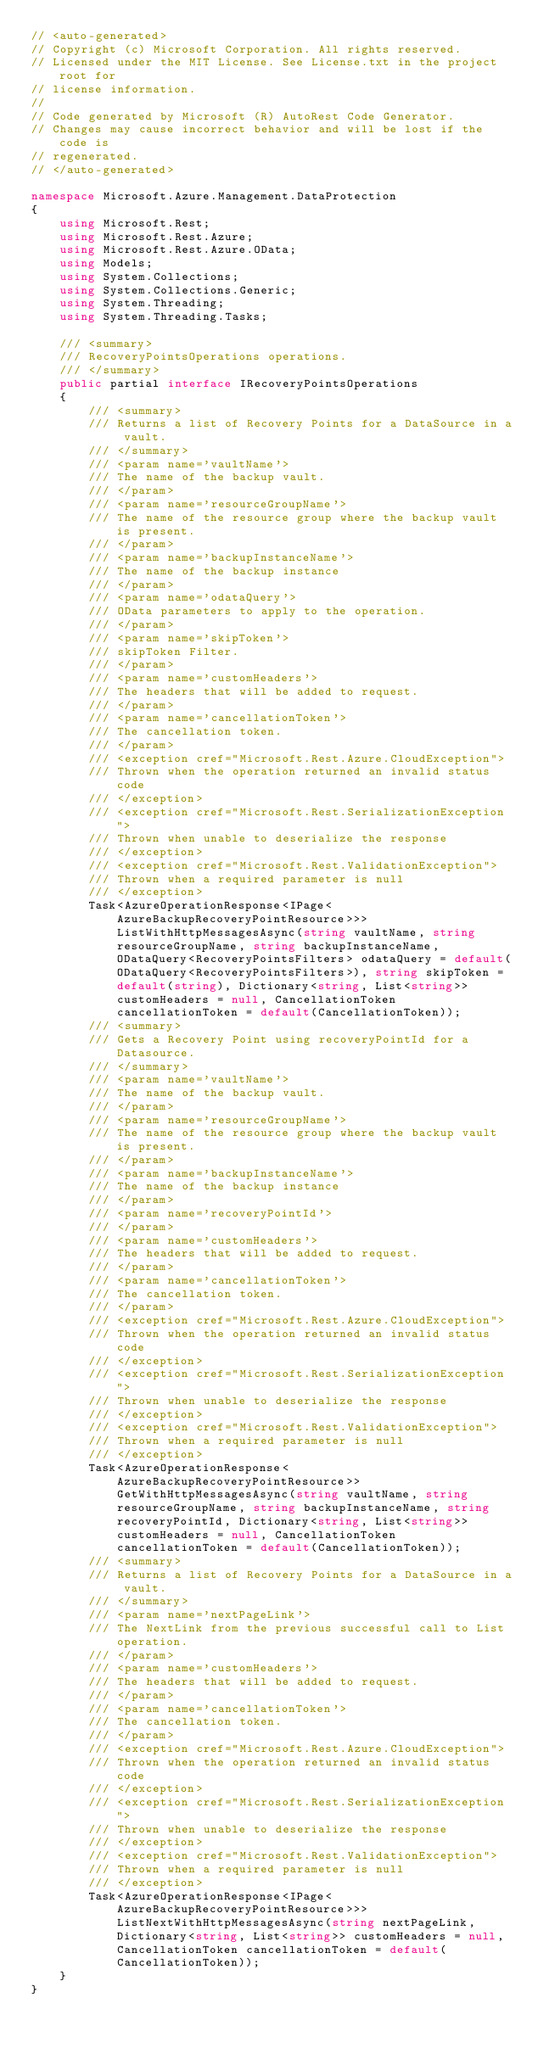Convert code to text. <code><loc_0><loc_0><loc_500><loc_500><_C#_>// <auto-generated>
// Copyright (c) Microsoft Corporation. All rights reserved.
// Licensed under the MIT License. See License.txt in the project root for
// license information.
//
// Code generated by Microsoft (R) AutoRest Code Generator.
// Changes may cause incorrect behavior and will be lost if the code is
// regenerated.
// </auto-generated>

namespace Microsoft.Azure.Management.DataProtection
{
    using Microsoft.Rest;
    using Microsoft.Rest.Azure;
    using Microsoft.Rest.Azure.OData;
    using Models;
    using System.Collections;
    using System.Collections.Generic;
    using System.Threading;
    using System.Threading.Tasks;

    /// <summary>
    /// RecoveryPointsOperations operations.
    /// </summary>
    public partial interface IRecoveryPointsOperations
    {
        /// <summary>
        /// Returns a list of Recovery Points for a DataSource in a vault.
        /// </summary>
        /// <param name='vaultName'>
        /// The name of the backup vault.
        /// </param>
        /// <param name='resourceGroupName'>
        /// The name of the resource group where the backup vault is present.
        /// </param>
        /// <param name='backupInstanceName'>
        /// The name of the backup instance
        /// </param>
        /// <param name='odataQuery'>
        /// OData parameters to apply to the operation.
        /// </param>
        /// <param name='skipToken'>
        /// skipToken Filter.
        /// </param>
        /// <param name='customHeaders'>
        /// The headers that will be added to request.
        /// </param>
        /// <param name='cancellationToken'>
        /// The cancellation token.
        /// </param>
        /// <exception cref="Microsoft.Rest.Azure.CloudException">
        /// Thrown when the operation returned an invalid status code
        /// </exception>
        /// <exception cref="Microsoft.Rest.SerializationException">
        /// Thrown when unable to deserialize the response
        /// </exception>
        /// <exception cref="Microsoft.Rest.ValidationException">
        /// Thrown when a required parameter is null
        /// </exception>
        Task<AzureOperationResponse<IPage<AzureBackupRecoveryPointResource>>> ListWithHttpMessagesAsync(string vaultName, string resourceGroupName, string backupInstanceName, ODataQuery<RecoveryPointsFilters> odataQuery = default(ODataQuery<RecoveryPointsFilters>), string skipToken = default(string), Dictionary<string, List<string>> customHeaders = null, CancellationToken cancellationToken = default(CancellationToken));
        /// <summary>
        /// Gets a Recovery Point using recoveryPointId for a Datasource.
        /// </summary>
        /// <param name='vaultName'>
        /// The name of the backup vault.
        /// </param>
        /// <param name='resourceGroupName'>
        /// The name of the resource group where the backup vault is present.
        /// </param>
        /// <param name='backupInstanceName'>
        /// The name of the backup instance
        /// </param>
        /// <param name='recoveryPointId'>
        /// </param>
        /// <param name='customHeaders'>
        /// The headers that will be added to request.
        /// </param>
        /// <param name='cancellationToken'>
        /// The cancellation token.
        /// </param>
        /// <exception cref="Microsoft.Rest.Azure.CloudException">
        /// Thrown when the operation returned an invalid status code
        /// </exception>
        /// <exception cref="Microsoft.Rest.SerializationException">
        /// Thrown when unable to deserialize the response
        /// </exception>
        /// <exception cref="Microsoft.Rest.ValidationException">
        /// Thrown when a required parameter is null
        /// </exception>
        Task<AzureOperationResponse<AzureBackupRecoveryPointResource>> GetWithHttpMessagesAsync(string vaultName, string resourceGroupName, string backupInstanceName, string recoveryPointId, Dictionary<string, List<string>> customHeaders = null, CancellationToken cancellationToken = default(CancellationToken));
        /// <summary>
        /// Returns a list of Recovery Points for a DataSource in a vault.
        /// </summary>
        /// <param name='nextPageLink'>
        /// The NextLink from the previous successful call to List operation.
        /// </param>
        /// <param name='customHeaders'>
        /// The headers that will be added to request.
        /// </param>
        /// <param name='cancellationToken'>
        /// The cancellation token.
        /// </param>
        /// <exception cref="Microsoft.Rest.Azure.CloudException">
        /// Thrown when the operation returned an invalid status code
        /// </exception>
        /// <exception cref="Microsoft.Rest.SerializationException">
        /// Thrown when unable to deserialize the response
        /// </exception>
        /// <exception cref="Microsoft.Rest.ValidationException">
        /// Thrown when a required parameter is null
        /// </exception>
        Task<AzureOperationResponse<IPage<AzureBackupRecoveryPointResource>>> ListNextWithHttpMessagesAsync(string nextPageLink, Dictionary<string, List<string>> customHeaders = null, CancellationToken cancellationToken = default(CancellationToken));
    }
}
</code> 